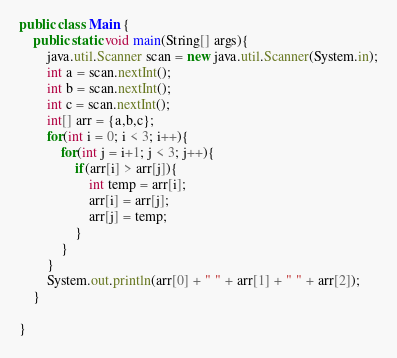<code> <loc_0><loc_0><loc_500><loc_500><_Java_>public class Main {
	public static void main(String[] args){
		java.util.Scanner scan = new java.util.Scanner(System.in);
		int a = scan.nextInt();
		int b = scan.nextInt();
		int c = scan.nextInt();
		int[] arr = {a,b,c};
		for(int i = 0; i < 3; i++){
			for(int j = i+1; j < 3; j++){
				if(arr[i] > arr[j]){
					int temp = arr[i];
					arr[i] = arr[j];
					arr[j] = temp;
				}
			}
		}
		System.out.println(arr[0] + " " + arr[1] + " " + arr[2]);
	}

}</code> 